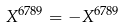<formula> <loc_0><loc_0><loc_500><loc_500>X ^ { 6 7 8 9 } = - X ^ { 6 7 8 9 }</formula> 